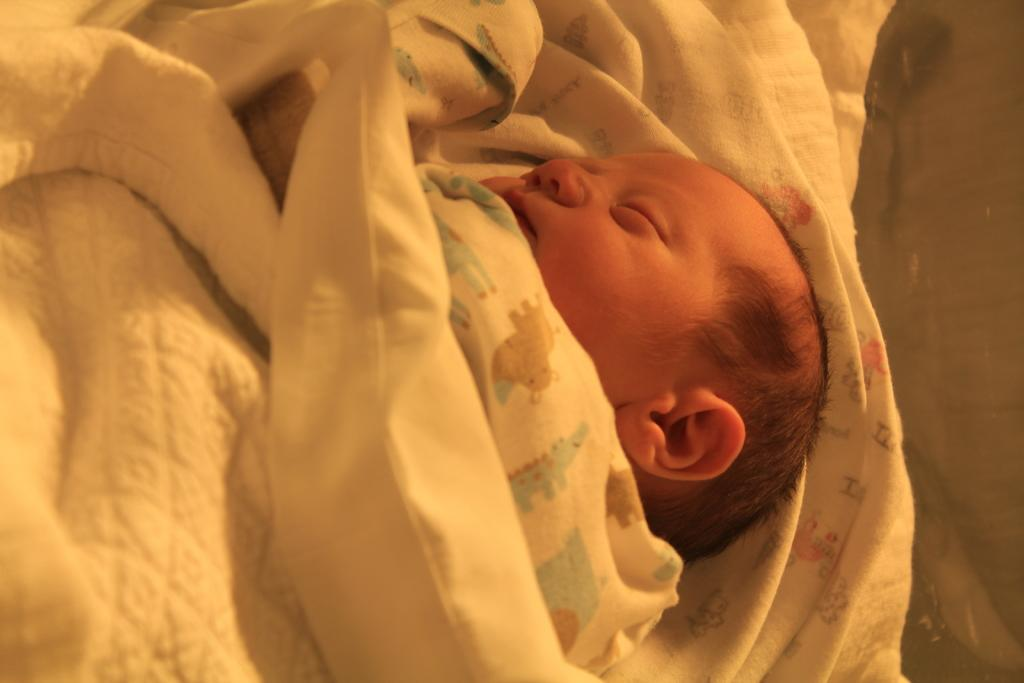What is the main subject of the picture? The main subject of the picture is an infant. What is the infant doing in the picture? The infant is sleeping in the picture. How is the infant positioned or covered in the picture? There are blankets covering the infant in the picture. What type of plastic is used to make the badge on the infant's chest in the image? There is no badge present on the infant's chest in the image. What type of lettuce is visible in the picture? There is no lettuce present in the image. 